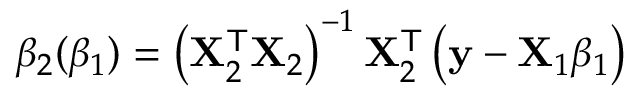<formula> <loc_0><loc_0><loc_500><loc_500>\beta _ { 2 } ( \beta _ { 1 } ) = \left ( X _ { 2 } ^ { T } X _ { 2 } \right ) ^ { - 1 } X _ { 2 } ^ { T } \left ( y - X _ { 1 } \beta _ { 1 } \right )</formula> 